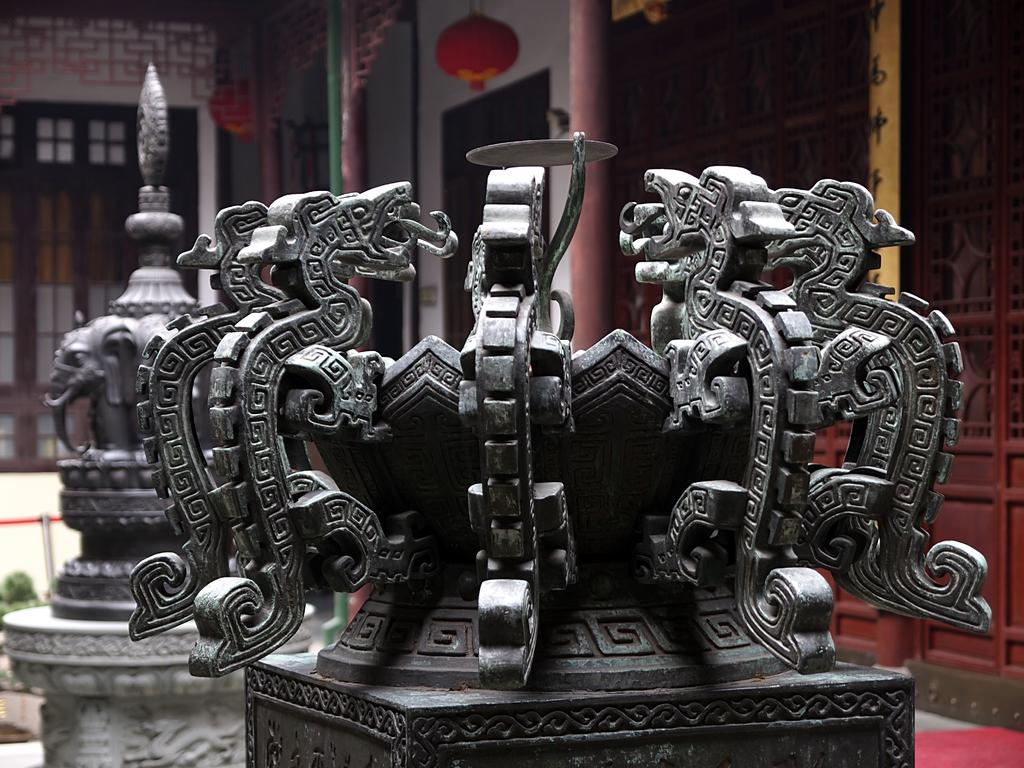What can be seen in the foreground of the image? There are sculptures in the foreground of the image. What is visible in the background of the image? There is a building, glass windows, poles, and a wall in the background of the image. Can you describe the unspecified objects in the background? Unfortunately, the provided facts do not specify the nature of the unspecified objects in the background. What type of rhythm is being played by the sculptures in the image? The sculptures in the image are not capable of playing any rhythm, as they are inanimate objects. Is there any poison visible in the image? There is no mention of poison in the provided facts, and therefore it cannot be determined if any is present in the image. 